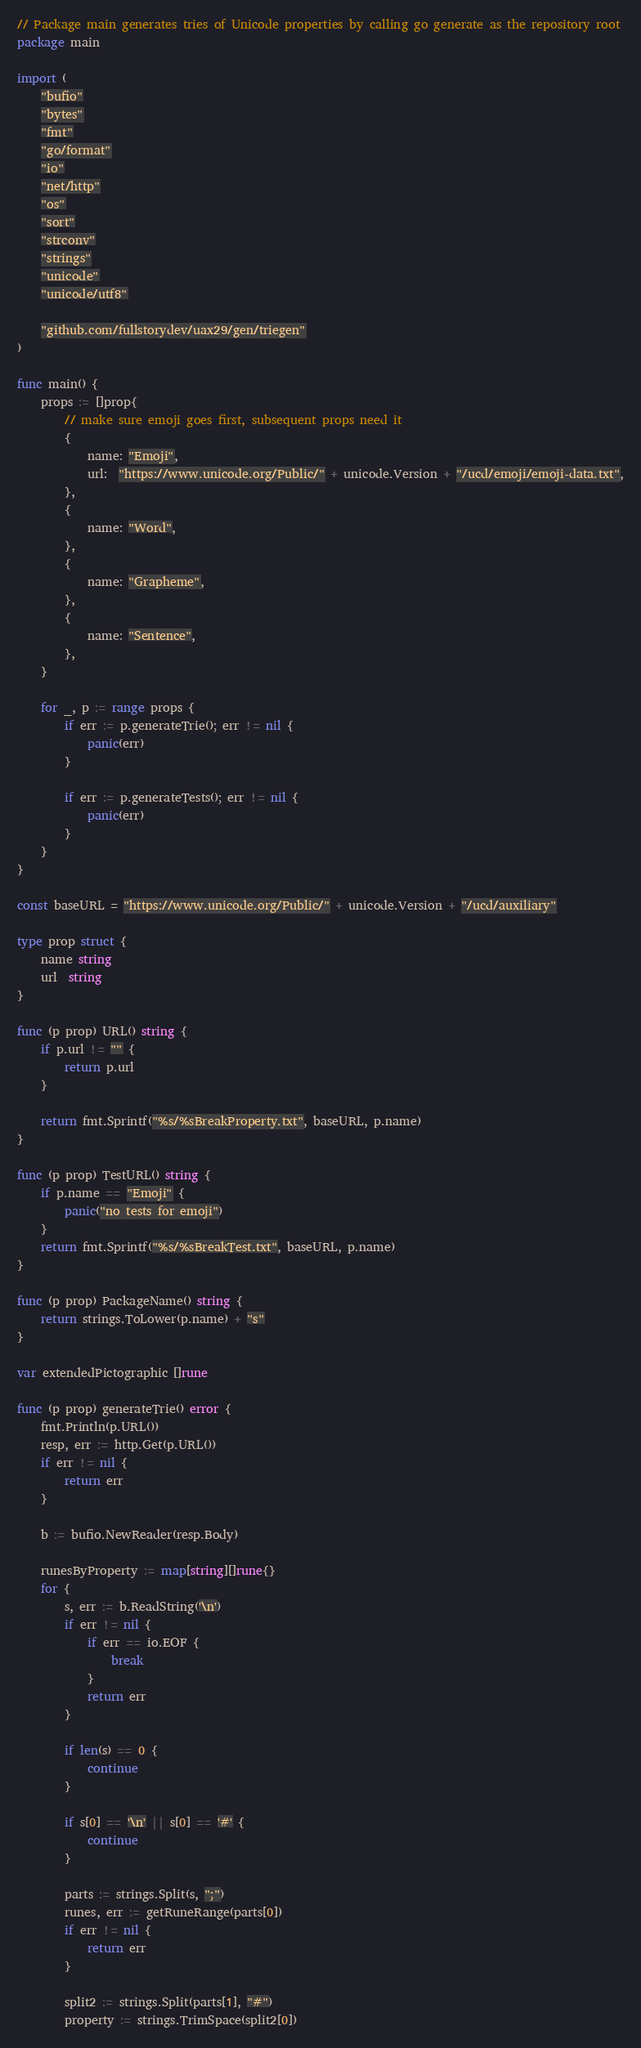Convert code to text. <code><loc_0><loc_0><loc_500><loc_500><_Go_>// Package main generates tries of Unicode properties by calling go generate as the repository root
package main

import (
	"bufio"
	"bytes"
	"fmt"
	"go/format"
	"io"
	"net/http"
	"os"
	"sort"
	"strconv"
	"strings"
	"unicode"
	"unicode/utf8"

	"github.com/fullstorydev/uax29/gen/triegen"
)

func main() {
	props := []prop{
		// make sure emoji goes first, subsequent props need it
		{
			name: "Emoji",
			url:  "https://www.unicode.org/Public/" + unicode.Version + "/ucd/emoji/emoji-data.txt",
		},
		{
			name: "Word",
		},
		{
			name: "Grapheme",
		},
		{
			name: "Sentence",
		},
	}

	for _, p := range props {
		if err := p.generateTrie(); err != nil {
			panic(err)
		}

		if err := p.generateTests(); err != nil {
			panic(err)
		}
	}
}

const baseURL = "https://www.unicode.org/Public/" + unicode.Version + "/ucd/auxiliary"

type prop struct {
	name string
	url  string
}

func (p prop) URL() string {
	if p.url != "" {
		return p.url
	}

	return fmt.Sprintf("%s/%sBreakProperty.txt", baseURL, p.name)
}

func (p prop) TestURL() string {
	if p.name == "Emoji" {
		panic("no tests for emoji")
	}
	return fmt.Sprintf("%s/%sBreakTest.txt", baseURL, p.name)
}

func (p prop) PackageName() string {
	return strings.ToLower(p.name) + "s"
}

var extendedPictographic []rune

func (p prop) generateTrie() error {
	fmt.Println(p.URL())
	resp, err := http.Get(p.URL())
	if err != nil {
		return err
	}

	b := bufio.NewReader(resp.Body)

	runesByProperty := map[string][]rune{}
	for {
		s, err := b.ReadString('\n')
		if err != nil {
			if err == io.EOF {
				break
			}
			return err
		}

		if len(s) == 0 {
			continue
		}

		if s[0] == '\n' || s[0] == '#' {
			continue
		}

		parts := strings.Split(s, ";")
		runes, err := getRuneRange(parts[0])
		if err != nil {
			return err
		}

		split2 := strings.Split(parts[1], "#")
		property := strings.TrimSpace(split2[0])
</code> 